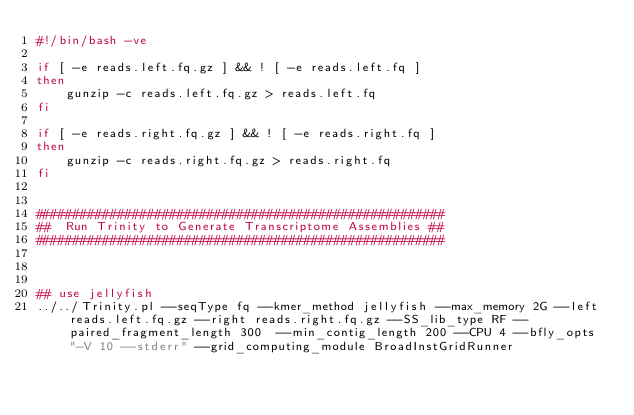Convert code to text. <code><loc_0><loc_0><loc_500><loc_500><_Bash_>#!/bin/bash -ve

if [ -e reads.left.fq.gz ] && ! [ -e reads.left.fq ]
then
    gunzip -c reads.left.fq.gz > reads.left.fq
fi

if [ -e reads.right.fq.gz ] && ! [ -e reads.right.fq ]
then
    gunzip -c reads.right.fq.gz > reads.right.fq
fi


#######################################################
##  Run Trinity to Generate Transcriptome Assemblies ##
#######################################################



## use jellyfish
../../Trinity.pl --seqType fq --kmer_method jellyfish --max_memory 2G --left reads.left.fq.gz --right reads.right.fq.gz --SS_lib_type RF --paired_fragment_length 300  --min_contig_length 200 --CPU 4 --bfly_opts "-V 10 --stderr" --grid_computing_module BroadInstGridRunner



</code> 